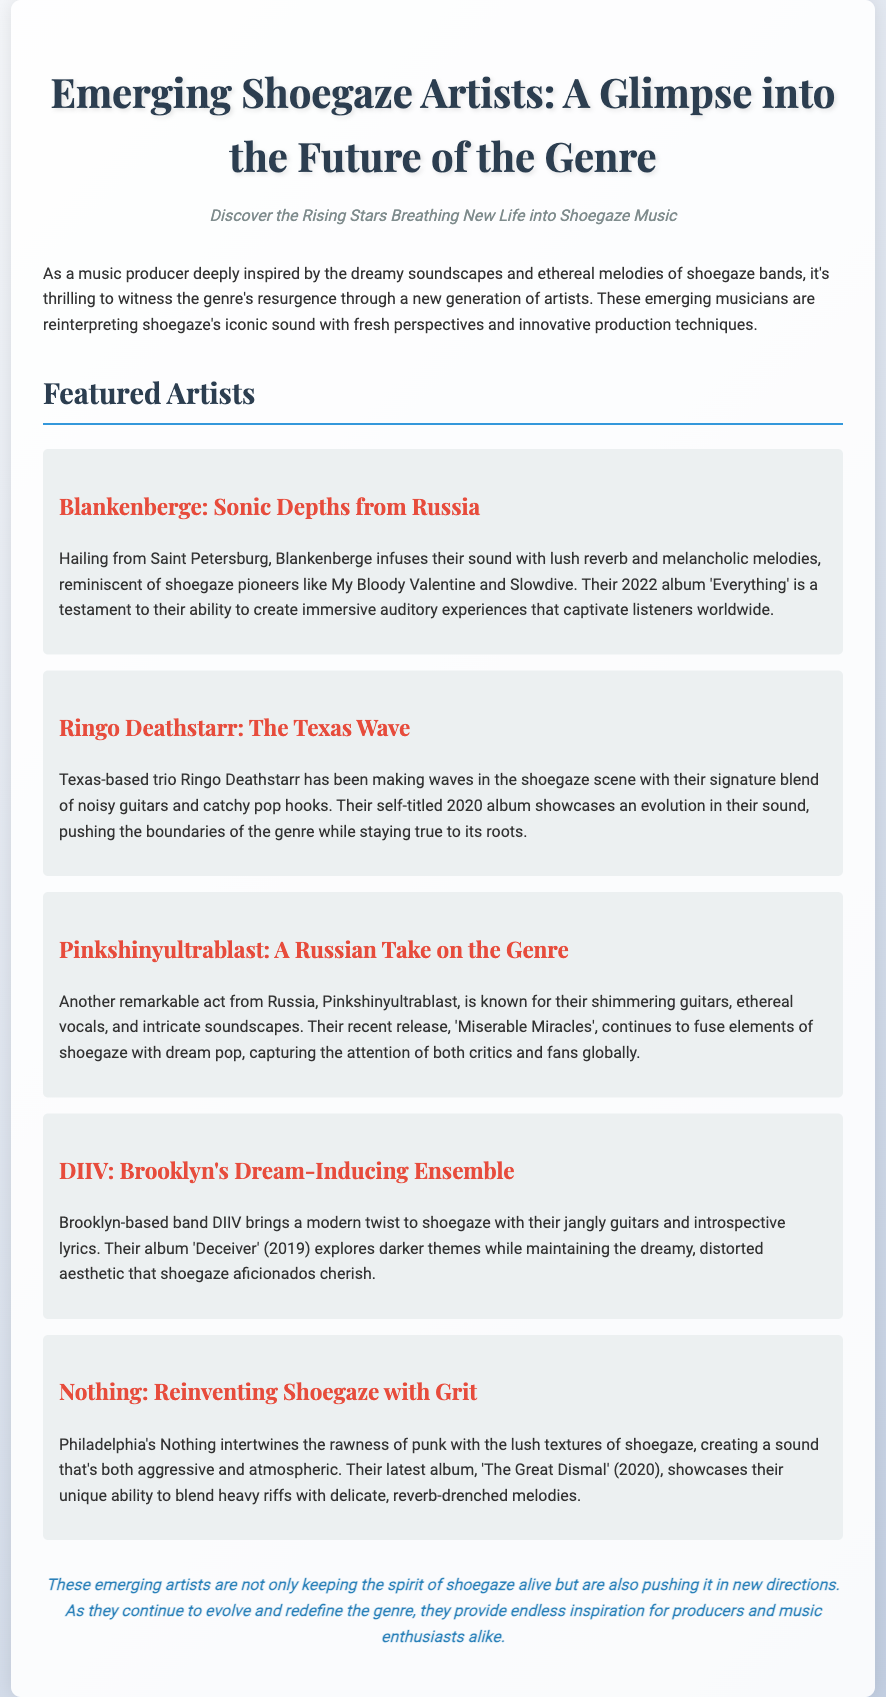What is the title of the press release? The title of the press release is prominently displayed at the top of the document, which is "Emerging Shoegaze Artists: A Glimpse into the Future of the Genre."
Answer: Emerging Shoegaze Artists: A Glimpse into the Future of the Genre Who is the artist from Saint Petersburg? Blankenberge is identified as the artist hailing from Saint Petersburg, with a description of their sound.
Answer: Blankenberge What year was DIIV's album "Deceiver" released? The document explicitly states that DIIV's album "Deceiver" was released in 2019.
Answer: 2019 Which artist is mentioned as being from Texas? Ringo Deathstarr is mentioned as the Texas-based trio making waves in the shoegaze scene.
Answer: Ringo Deathstarr How many artists are featured in the press release? The document lists five emerging artists under the "Featured Artists" section.
Answer: Five What does Pinkshinyultrablast's recent release fuse together? The document indicates that Pinkshinyultrablast's recent release fuses elements of shoegaze with dream pop.
Answer: Shoegaze and dream pop Which city is Nothing based in? The document specifies that the band Nothing is based in Philadelphia.
Answer: Philadelphia What are the recent themes explored in DIIV's music? The press release mentions that DIIV explores darker themes in their music, maintaining the dreamy aesthetic.
Answer: Darker themes What is the concluding statement in the press release? The conclusion section of the document summarizes the impact of emerging artists on the shoegaze genre.
Answer: These emerging artists are not only keeping the spirit of shoegaze alive but are also pushing it in new directions 